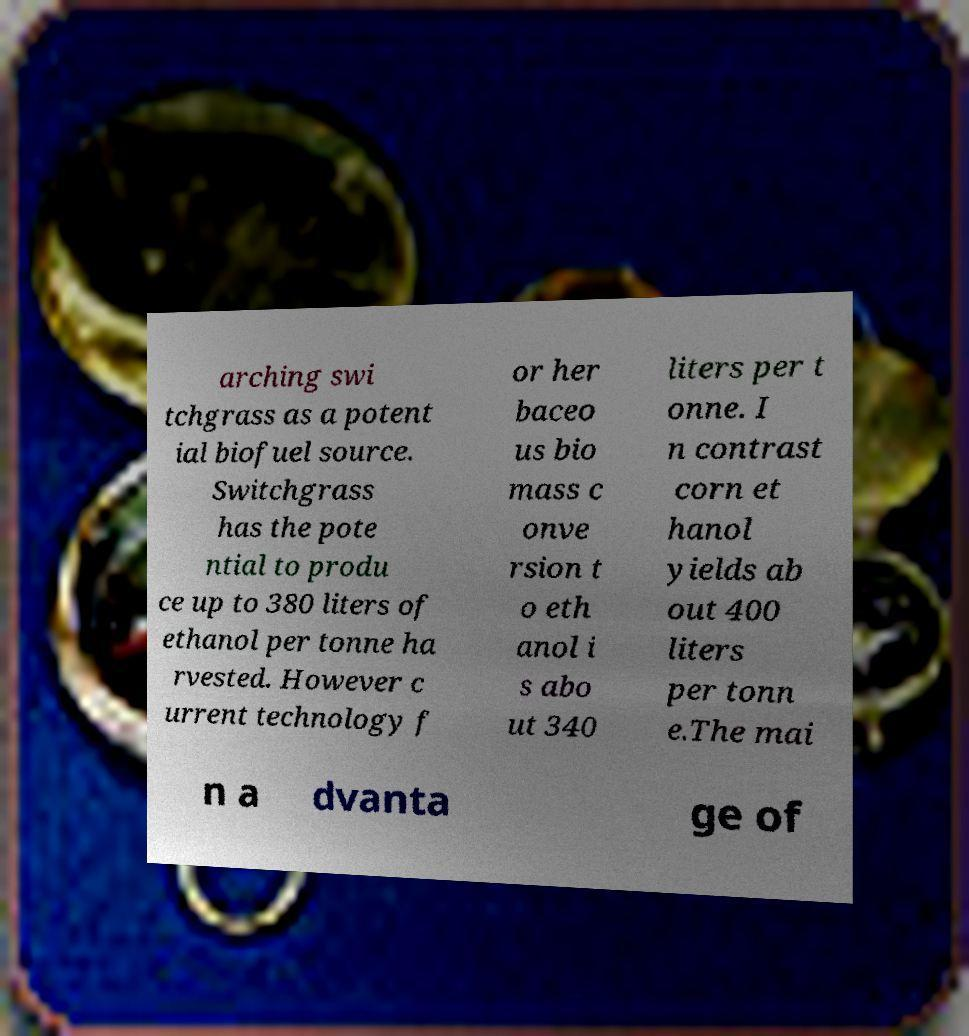What messages or text are displayed in this image? I need them in a readable, typed format. arching swi tchgrass as a potent ial biofuel source. Switchgrass has the pote ntial to produ ce up to 380 liters of ethanol per tonne ha rvested. However c urrent technology f or her baceo us bio mass c onve rsion t o eth anol i s abo ut 340 liters per t onne. I n contrast corn et hanol yields ab out 400 liters per tonn e.The mai n a dvanta ge of 